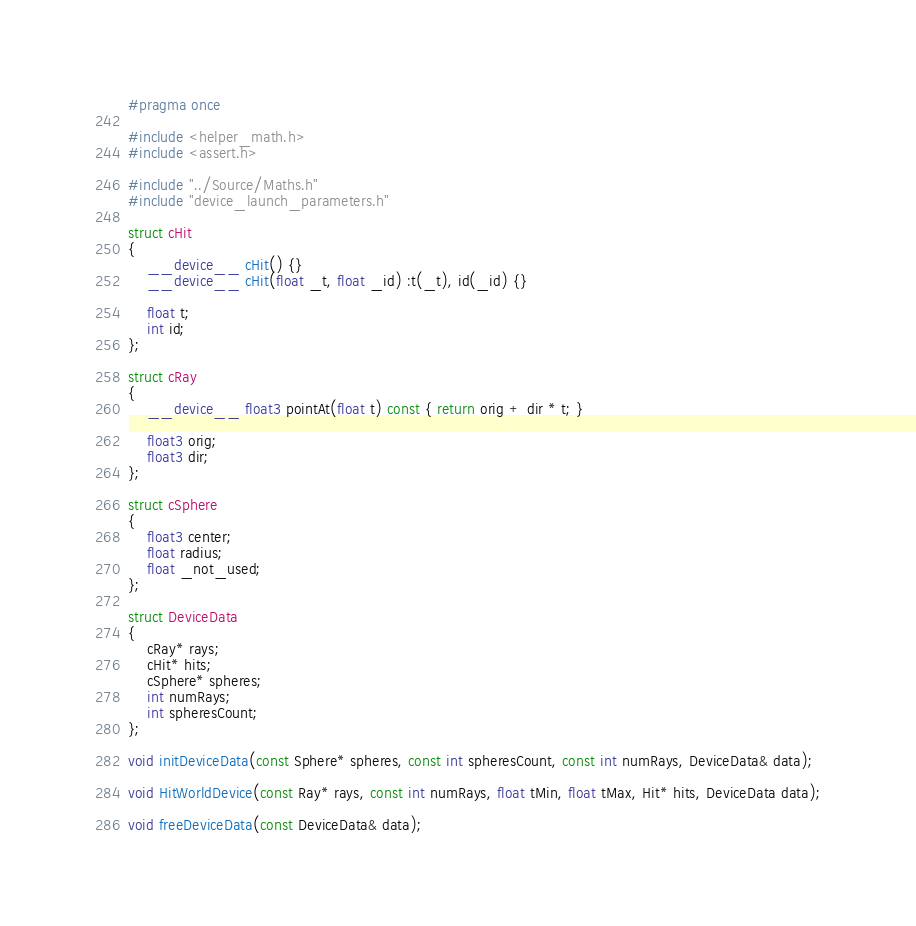Convert code to text. <code><loc_0><loc_0><loc_500><loc_500><_Cuda_>#pragma once

#include <helper_math.h>
#include <assert.h>

#include "../Source/Maths.h"
#include "device_launch_parameters.h"

struct cHit
{
    __device__ cHit() {}
    __device__ cHit(float _t, float _id) :t(_t), id(_id) {}

    float t;
    int id;
};

struct cRay
{
    __device__ float3 pointAt(float t) const { return orig + dir * t; }

    float3 orig;
    float3 dir;
};

struct cSphere
{
    float3 center;
    float radius;
    float _not_used;
};

struct DeviceData
{
    cRay* rays;
    cHit* hits;
    cSphere* spheres;
    int numRays;
    int spheresCount;
};

void initDeviceData(const Sphere* spheres, const int spheresCount, const int numRays, DeviceData& data);

void HitWorldDevice(const Ray* rays, const int numRays, float tMin, float tMax, Hit* hits, DeviceData data);

void freeDeviceData(const DeviceData& data);
</code> 